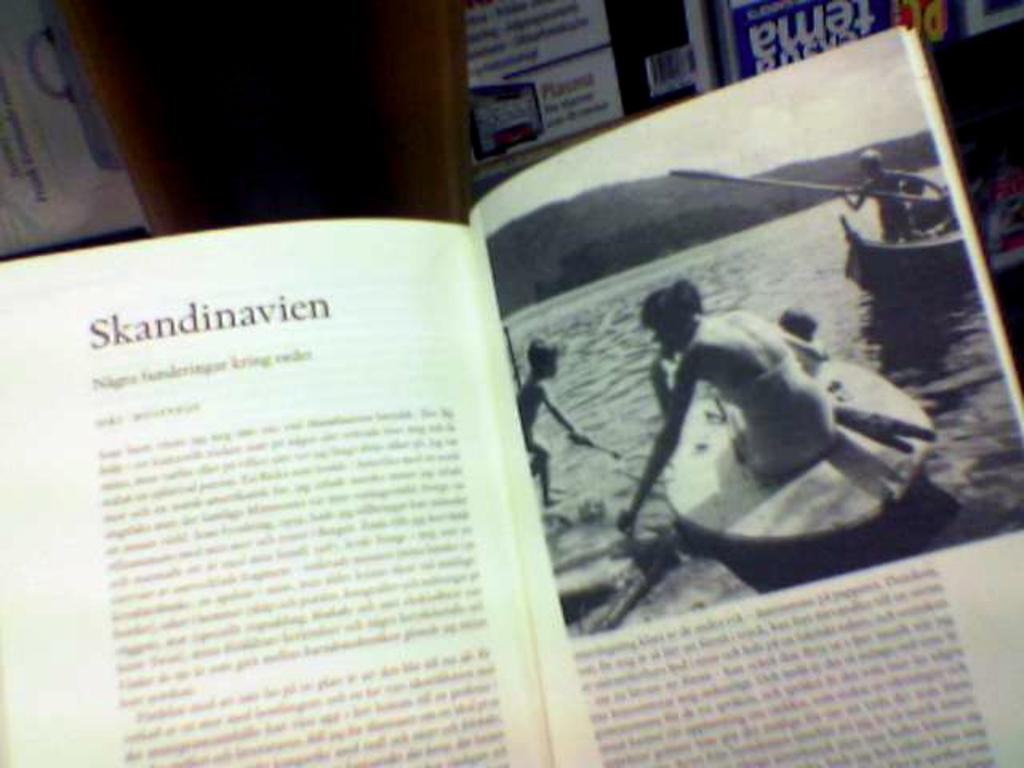<image>
Relay a brief, clear account of the picture shown. An open book with the headline "Skandinavien" and an illustration of children on a boat. 